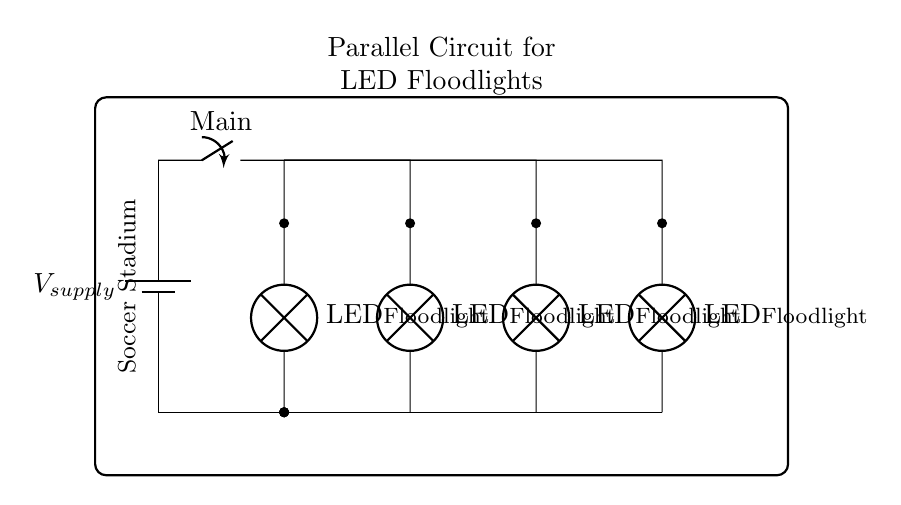What is the power source in the circuit? The power source in the circuit is identified by the component labeled as a battery. This component provides the necessary voltage to power the entire circuit, which includes the LED floodlights.
Answer: battery How many LED floodlights are in parallel? By observing the circuit, there are four branches depicted, each leading to an LED floodlight. Each branch represents one floodlight connected in parallel, allowing them to operate independently.
Answer: four What happens if one LED floodlight fails? In a parallel circuit configuration, if one LED floodlight fails, the other floodlights will continue to operate unaffected. This is due to each floodlight being on a separate branch of the circuit.
Answer: other floodlights remain on What is the effect of adding more LED floodlights in parallel? Adding more floodlights in parallel will increase the total current drawn from the power source, while the voltage across each floodlight remains constant. This means the power supply must be capable of providing the additional current.
Answer: increases current demand What is the role of the main switch in the circuit? The main switch allows for the complete shutting off of power to the circuit when needed. By opening the switch, the flow of electricity to all branches, including the LED floodlights, is interrupted.
Answer: controls circuit power What is the voltage across each LED floodlight? In a parallel circuit, the voltage across each component is the same as the supply voltage. Therefore, if the supply voltage is known, that will also be the voltage across each LED floodlight.
Answer: supply voltage 